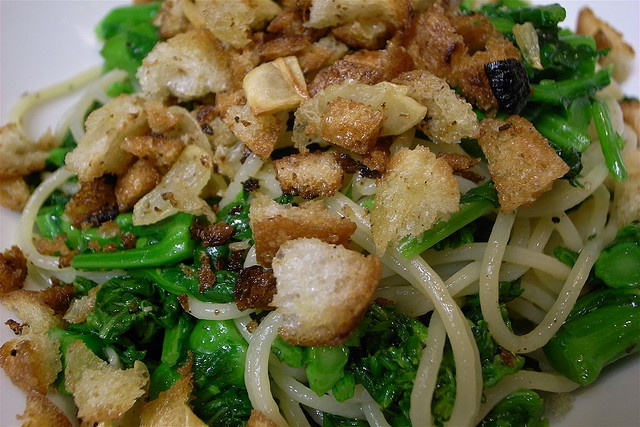Describe the objects in this image and their specific colors. I can see broccoli in lightgray and darkgreen tones, broccoli in lightgray, darkgreen, and green tones, broccoli in lightgray, black, and darkgreen tones, broccoli in lightgray, darkgreen, and green tones, and broccoli in lightgray, black, darkgreen, and gray tones in this image. 